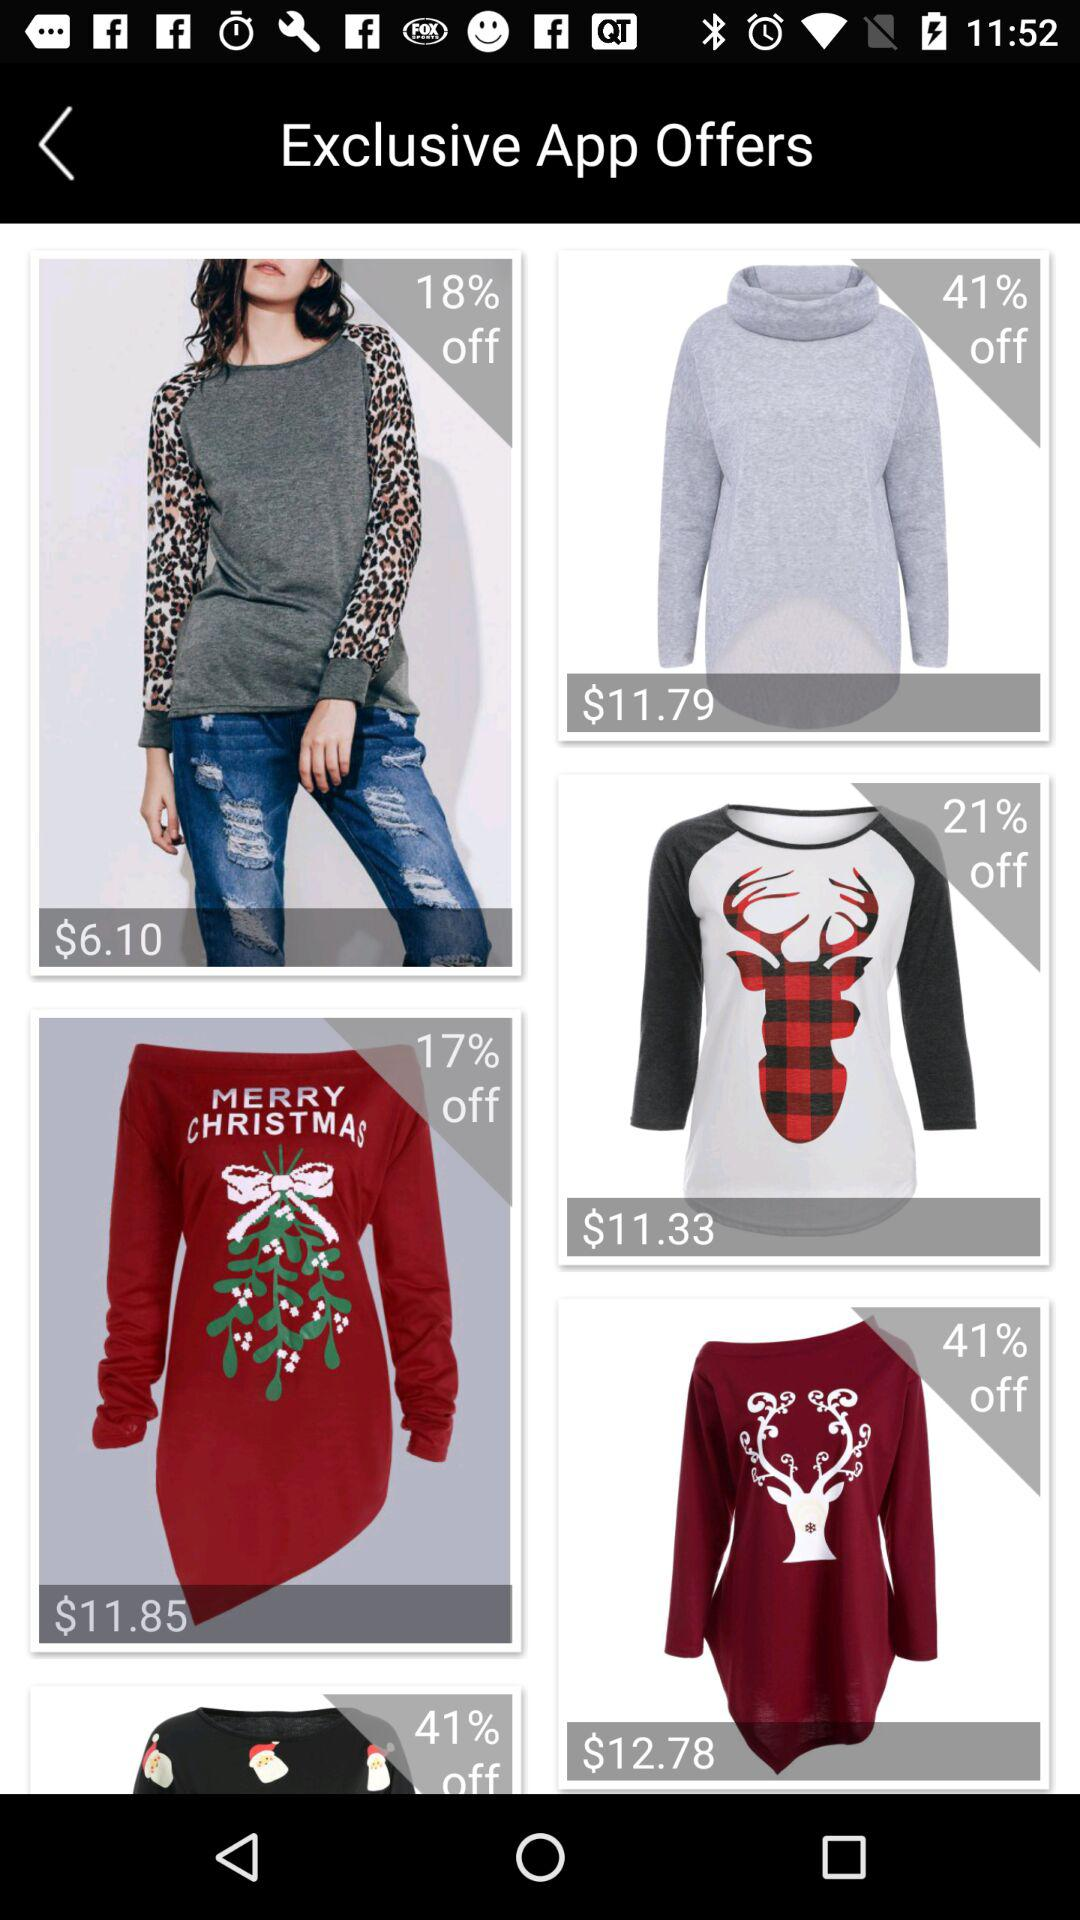How many items have a price over $10?
Answer the question using a single word or phrase. 4 